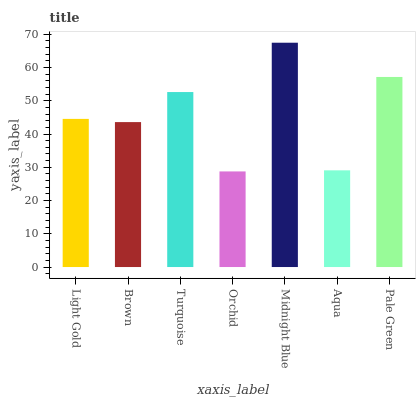Is Brown the minimum?
Answer yes or no. No. Is Brown the maximum?
Answer yes or no. No. Is Light Gold greater than Brown?
Answer yes or no. Yes. Is Brown less than Light Gold?
Answer yes or no. Yes. Is Brown greater than Light Gold?
Answer yes or no. No. Is Light Gold less than Brown?
Answer yes or no. No. Is Light Gold the high median?
Answer yes or no. Yes. Is Light Gold the low median?
Answer yes or no. Yes. Is Midnight Blue the high median?
Answer yes or no. No. Is Orchid the low median?
Answer yes or no. No. 